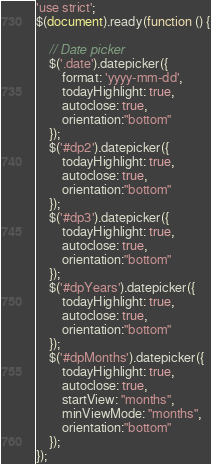<code> <loc_0><loc_0><loc_500><loc_500><_JavaScript_>'use strict';
$(document).ready(function () {

    // Date picker
    $('.date').datepicker({
        format: 'yyyy-mm-dd',
        todayHighlight: true,
        autoclose: true,
        orientation:"bottom"
    });
    $('#dp2').datepicker({
        todayHighlight: true,
        autoclose: true,
        orientation:"bottom"
    });
    $('#dp3').datepicker({
        todayHighlight: true,
        autoclose: true,
        orientation:"bottom"
    });
    $('#dpYears').datepicker({
        todayHighlight: true,
        autoclose: true,
        orientation:"bottom"
    });
    $('#dpMonths').datepicker({
        todayHighlight: true,
        autoclose: true,
        startView: "months",
        minViewMode: "months",
        orientation:"bottom"
    });
});</code> 